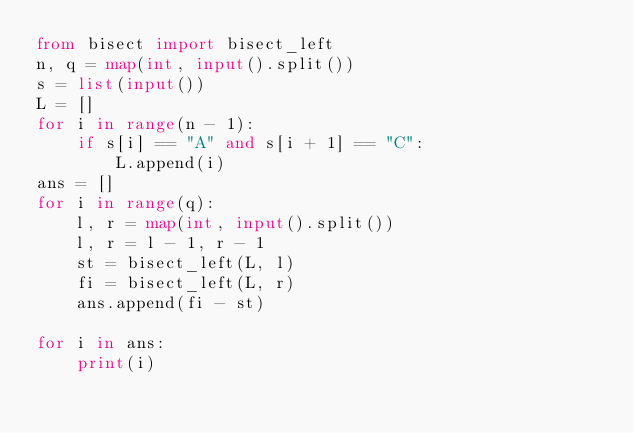Convert code to text. <code><loc_0><loc_0><loc_500><loc_500><_Python_>from bisect import bisect_left
n, q = map(int, input().split())
s = list(input())
L = []
for i in range(n - 1):
    if s[i] == "A" and s[i + 1] == "C":
        L.append(i)
ans = []
for i in range(q):
    l, r = map(int, input().split())
    l, r = l - 1, r - 1
    st = bisect_left(L, l)
    fi = bisect_left(L, r)
    ans.append(fi - st)

for i in ans:
    print(i)</code> 